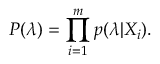Convert formula to latex. <formula><loc_0><loc_0><loc_500><loc_500>P ( \lambda ) = \prod _ { i = 1 } ^ { m } p ( \lambda | X _ { i } ) .</formula> 